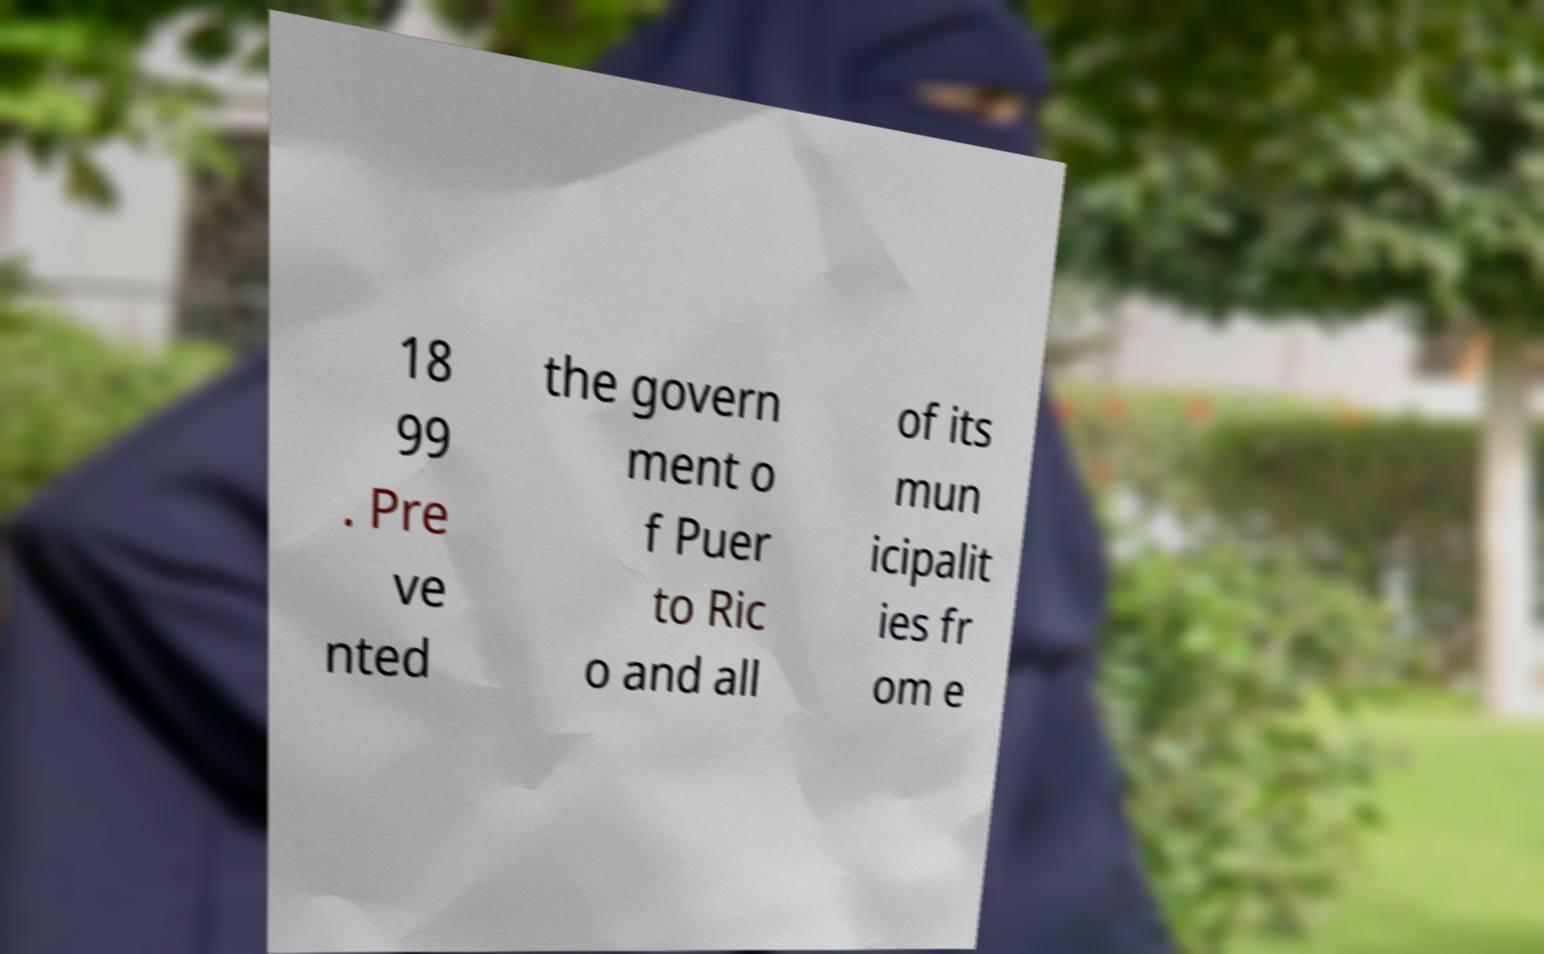I need the written content from this picture converted into text. Can you do that? 18 99 . Pre ve nted the govern ment o f Puer to Ric o and all of its mun icipalit ies fr om e 